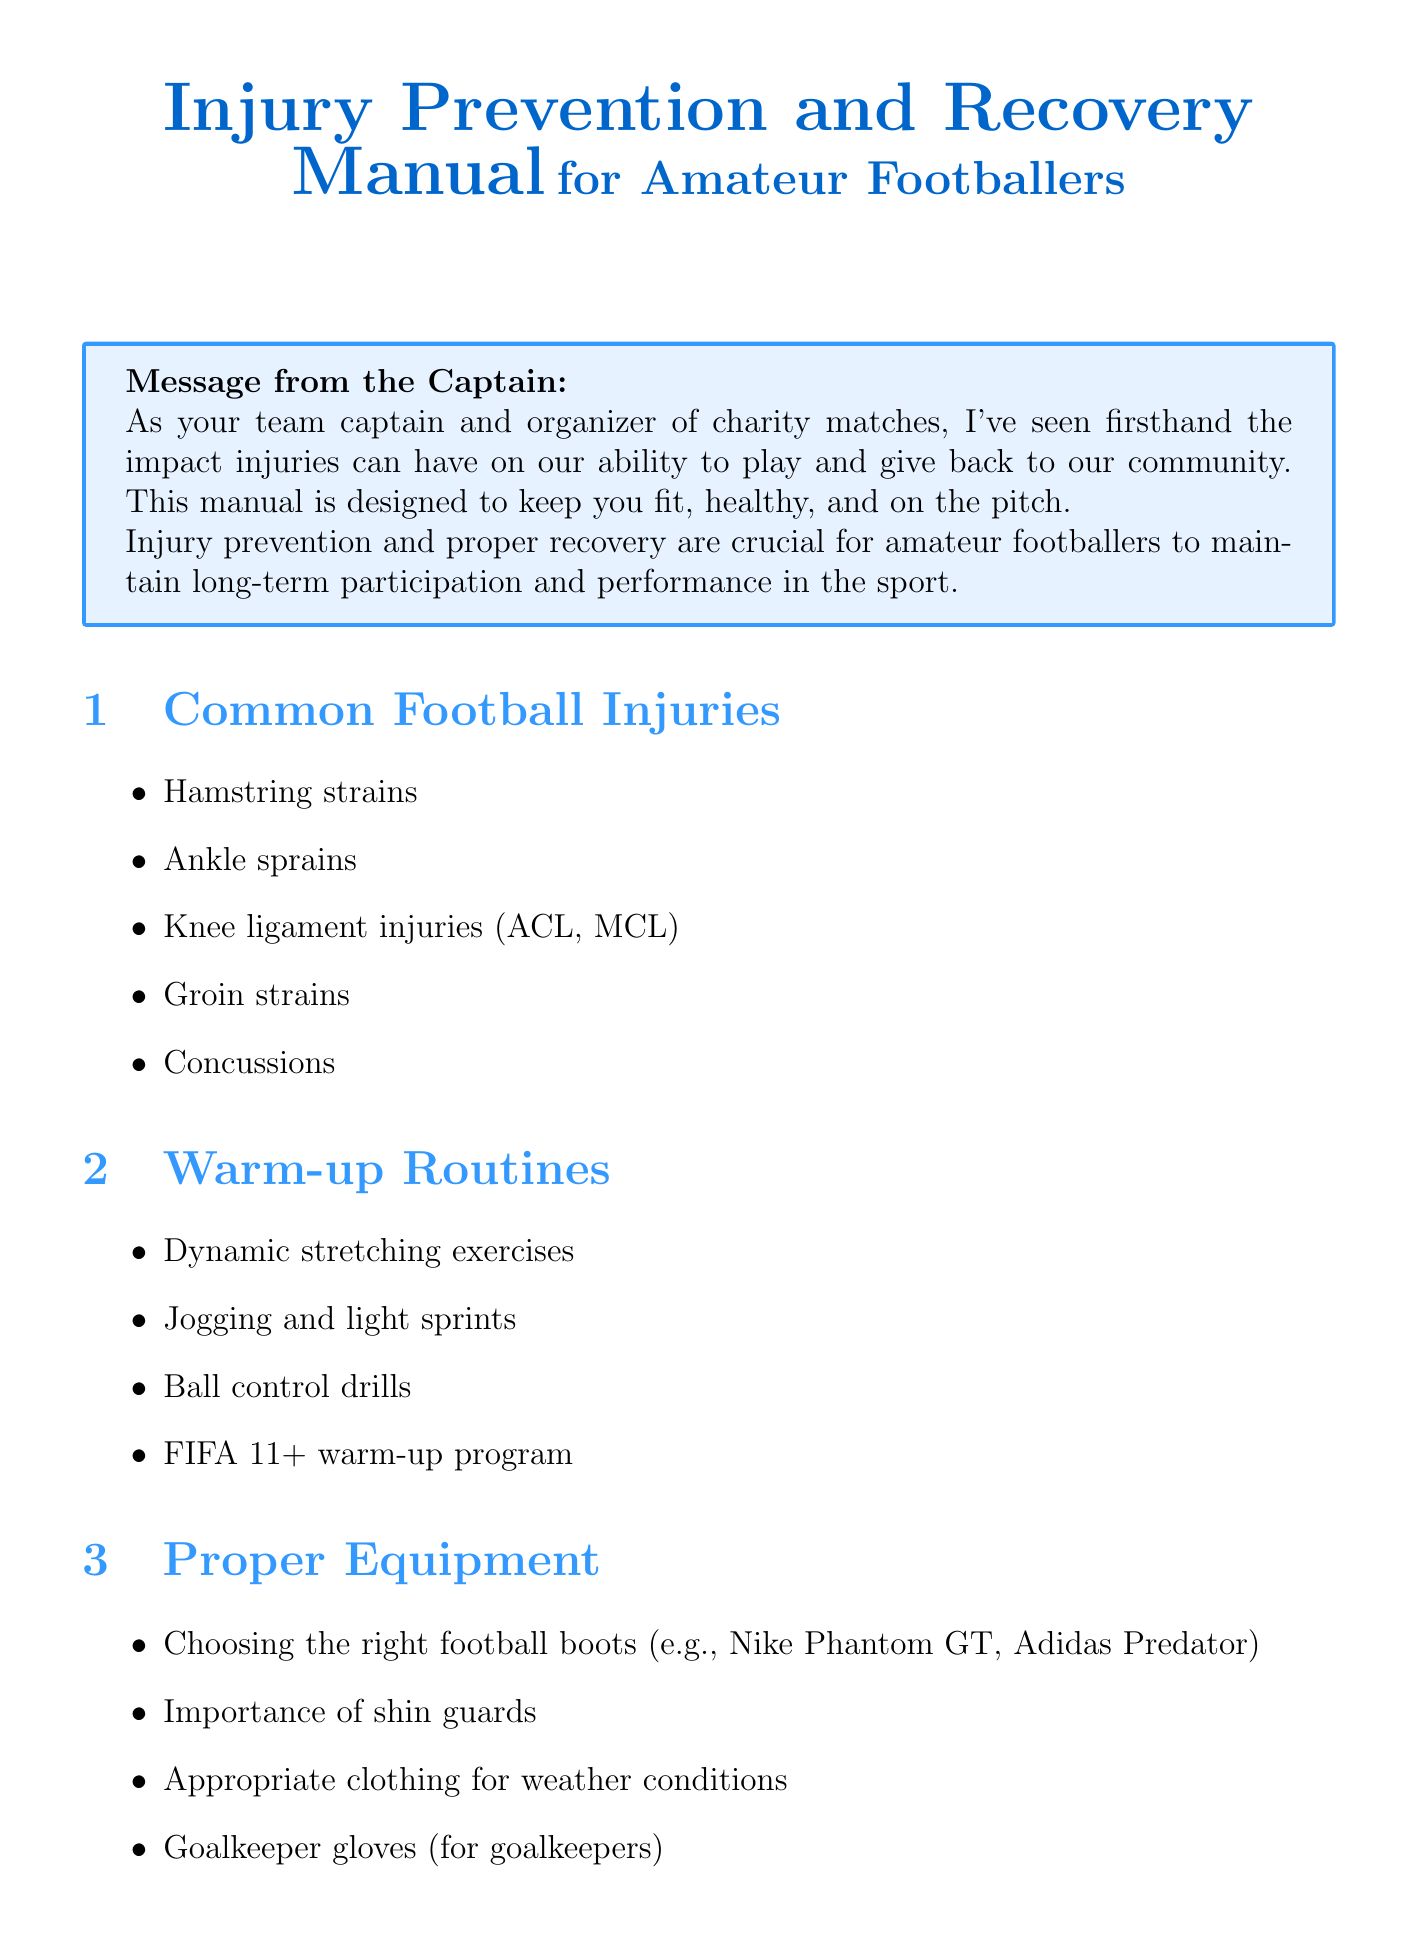What are common football injuries? The document lists several common football injuries, including Hamstring strains and Ankle sprains.
Answer: Hamstring strains, Ankle sprains, Knee ligament injuries (ACL, MCL), Groin strains, Concussions What is the FIFA 11+ program? The FIFA 11+ is mentioned as part of the warm-up routines in the document, indicating its importance for football players.
Answer: FIFA 11+ warm-up program What should a pre-match meal include? The document emphasizes a balanced diet rich in protein and complex carbohydrates for injury prevention, which relates to pre-match meal suggestions.
Answer: Balanced diet rich in protein and complex carbohydrates What technique is used for initial injury treatment? The document describes the RICE method as a first aid approach for common injuries, indicating its significance in treatment.
Answer: RICE method (Rest, Ice, Compression, Elevation) What is one mental health technique mentioned? The document discusses stress management techniques as part of mental health and injury prevention strategies.
Answer: Stress management techniques Who is the team physiotherapist? The document provides emergency contact information that includes the name of the team physiotherapist and her contact number.
Answer: Sarah Johnson What is included in recovery techniques? The document lists proper cool-down routines and ice baths as part of the recovery techniques for athletes.
Answer: Proper cool-down routines, Ice baths and contrast therapy What is crucial for hydration? The document mentions hydration in several contexts, particularly its necessity before, during, and after matches.
Answer: Before, during, and after matches What should be monitored during rehabilitation? The document emphasizes the importance of monitoring pain and discomfort when returning to play after an injury.
Answer: Monitoring pain and discomfort 